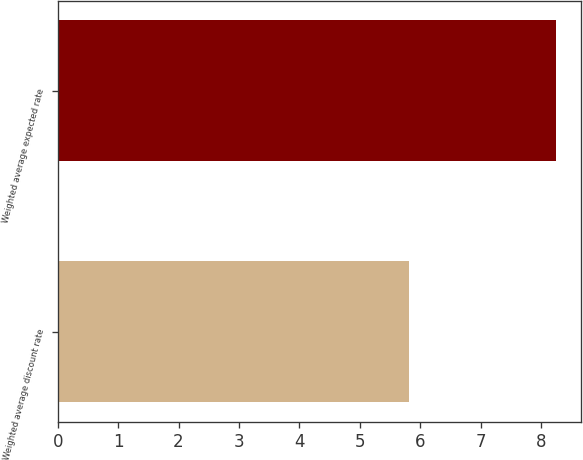Convert chart. <chart><loc_0><loc_0><loc_500><loc_500><bar_chart><fcel>Weighted average discount rate<fcel>Weighted average expected rate<nl><fcel>5.82<fcel>8.25<nl></chart> 